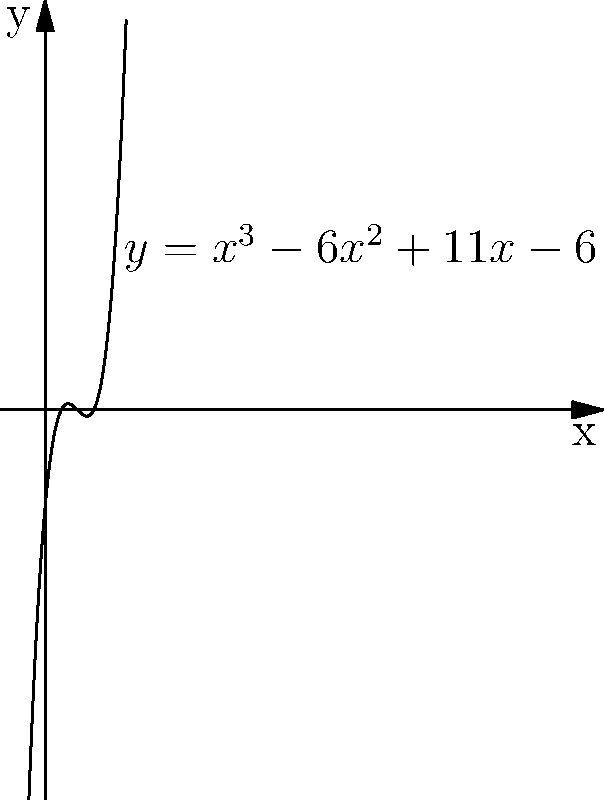In a small town, the number of unsolved cases over the years can be represented by the polynomial function $f(x) = x^3 - 6x^2 + 11x - 6$, where $x$ represents the number of years since the town's founding and $f(x)$ represents the number of unsolved cases. As the local crime fiction writer, you're researching the town's history for your next novel. How many times in the town's history did the number of unsolved cases reach zero? To find how many times the number of unsolved cases reached zero, we need to find the roots of the polynomial equation:

1) Set $f(x) = 0$:
   $x^3 - 6x^2 + 11x - 6 = 0$

2) This is a cubic equation. By inspection or using the rational root theorem, we can guess that $x = 1$ is a solution.

3) Factoring out $(x - 1)$:
   $(x - 1)(x^2 - 5x + 6) = 0$

4) The quadratic term can be factored:
   $(x - 1)(x - 2)(x - 3) = 0$

5) The roots of this equation are $x = 1$, $x = 2$, and $x = 3$.

6) These three roots represent the years when the number of unsolved cases was zero.

Therefore, the number of unsolved cases reached zero three times in the town's history.
Answer: 3 times 